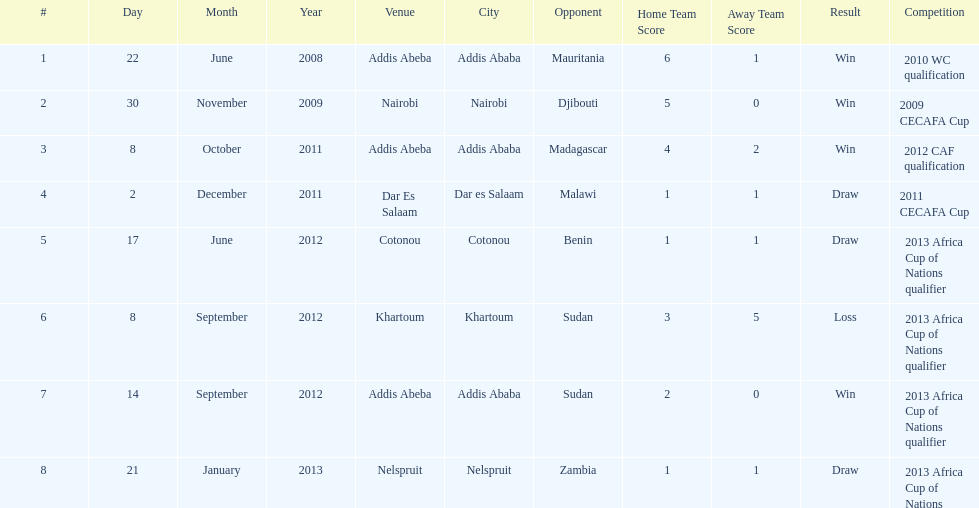How long in years down this table cover? 5. 